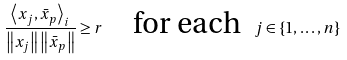<formula> <loc_0><loc_0><loc_500><loc_500>\frac { \left \langle x _ { j } , \bar { x } _ { p } \right \rangle _ { i } } { \left \| x _ { j } \right \| \left \| \bar { x } _ { p } \right \| } \geq r \quad \text {for each \ } j \in \left \{ 1 , \dots , n \right \}</formula> 